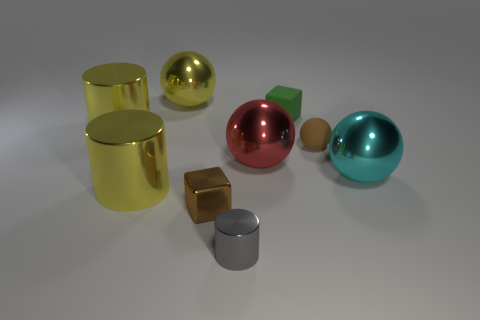Are there an equal number of brown matte balls that are in front of the green matte object and gray metallic cylinders that are behind the small brown rubber sphere?
Your answer should be compact. No. The small brown thing in front of the large thing that is right of the small cube that is behind the large red thing is what shape?
Provide a short and direct response. Cube. Is the large yellow thing that is in front of the large red metallic sphere made of the same material as the large sphere that is behind the brown matte object?
Your response must be concise. Yes. There is a big thing to the right of the matte block; what is its shape?
Provide a short and direct response. Sphere. Is the number of small things less than the number of brown balls?
Your answer should be compact. No. Is there a rubber block left of the large yellow metallic cylinder in front of the large shiny cylinder that is behind the big cyan shiny thing?
Provide a short and direct response. No. What number of metallic objects are either red things or large cyan things?
Provide a succinct answer. 2. Do the matte sphere and the tiny cylinder have the same color?
Provide a succinct answer. No. There is a big red object; what number of small gray objects are behind it?
Provide a succinct answer. 0. What number of spheres are both on the right side of the tiny ball and to the left of the cyan sphere?
Provide a short and direct response. 0. 